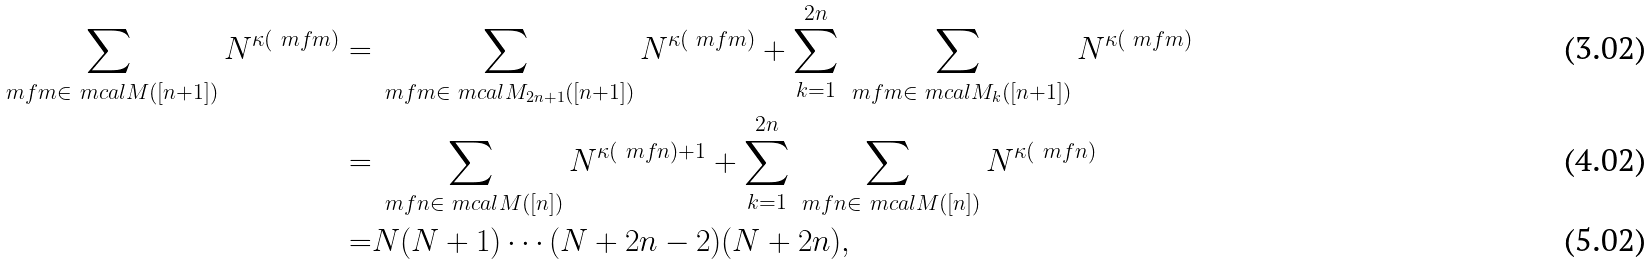<formula> <loc_0><loc_0><loc_500><loc_500>\sum _ { \ m f { m } \in \ m c a l { M } ( [ n + 1 ] ) } N ^ { \kappa ( \ m f { m } ) } = & \sum _ { \ m f { m } \in \ m c a l { M } _ { 2 n + 1 } ( [ n + 1 ] ) } N ^ { \kappa ( \ m f { m } ) } + \sum _ { k = 1 } ^ { 2 n } \sum _ { \ m f { m } \in \ m c a l { M } _ { k } ( [ n + 1 ] ) } N ^ { \kappa ( \ m f { m } ) } \\ = & \sum _ { \ m f { n } \in \ m c a l { M } ( [ n ] ) } N ^ { \kappa ( \ m f { n } ) + 1 } + \sum _ { k = 1 } ^ { 2 n } \sum _ { \ m f { n } \in \ m c a l { M } ( [ n ] ) } N ^ { \kappa ( \ m f { n } ) } \\ = & N ( N + 1 ) \cdots ( N + 2 n - 2 ) ( N + 2 n ) ,</formula> 